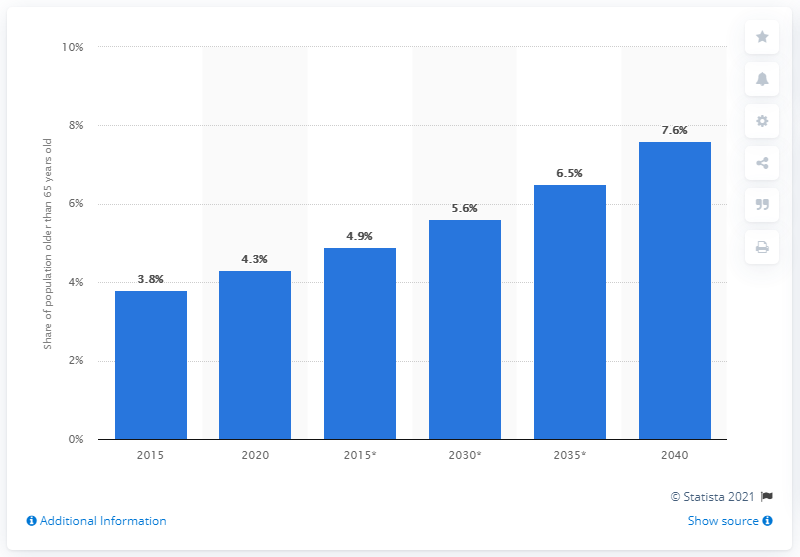Draw attention to some important aspects in this diagram. In 2020, the population in Laos was approximately 4.3 years old. The prediction was made that by the year 2040, 7.6 percent of Laos' population would be 65 years or older. 